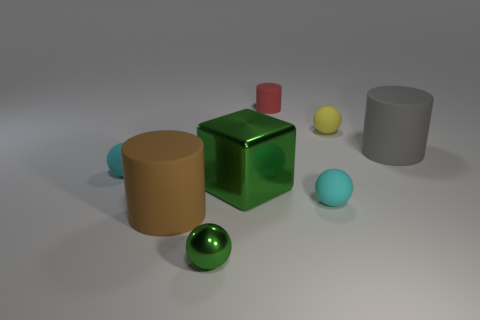How many other objects are the same material as the large gray cylinder?
Give a very brief answer. 5. What is the color of the other large thing that is the same shape as the big brown object?
Offer a very short reply. Gray. Does the matte thing to the right of the yellow ball have the same size as the large cube?
Ensure brevity in your answer.  Yes. Are there fewer cubes on the right side of the small cylinder than matte cylinders that are left of the big shiny block?
Your response must be concise. Yes. Is the big cube the same color as the tiny matte cylinder?
Provide a succinct answer. No. Are there fewer red rubber cylinders right of the red matte cylinder than large blue objects?
Your answer should be compact. No. There is a sphere that is the same color as the big shiny cube; what is it made of?
Your response must be concise. Metal. Are the green sphere and the small red thing made of the same material?
Ensure brevity in your answer.  No. What number of small red things have the same material as the yellow object?
Offer a terse response. 1. There is a large thing that is the same material as the gray cylinder; what color is it?
Ensure brevity in your answer.  Brown. 